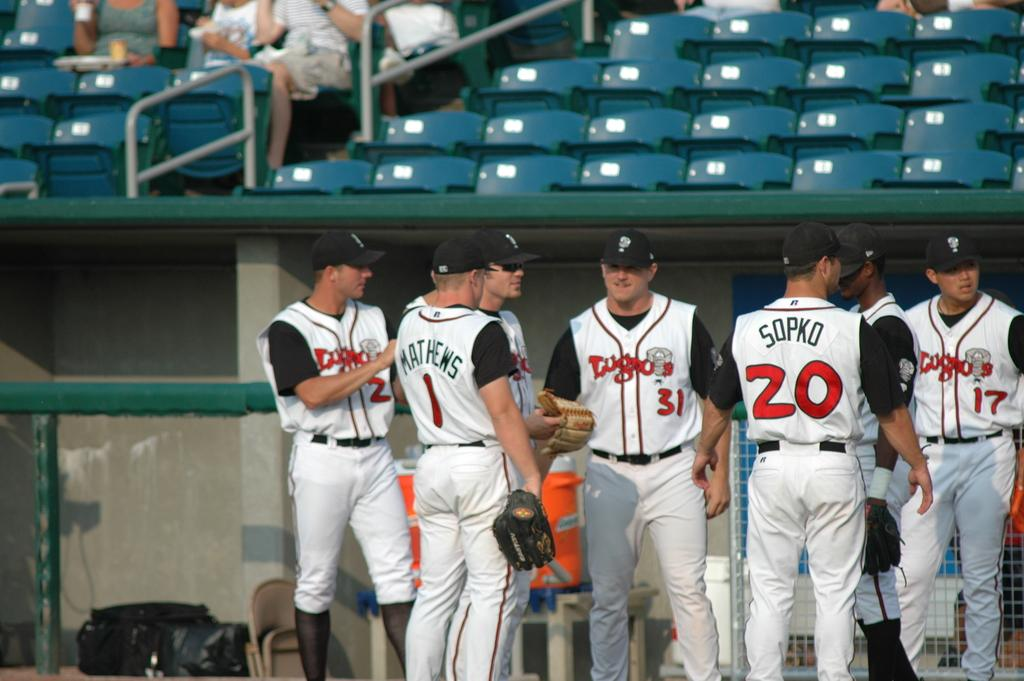Provide a one-sentence caption for the provided image. Several baseball players, including Matthews and Sopko, stand near the dugout. 